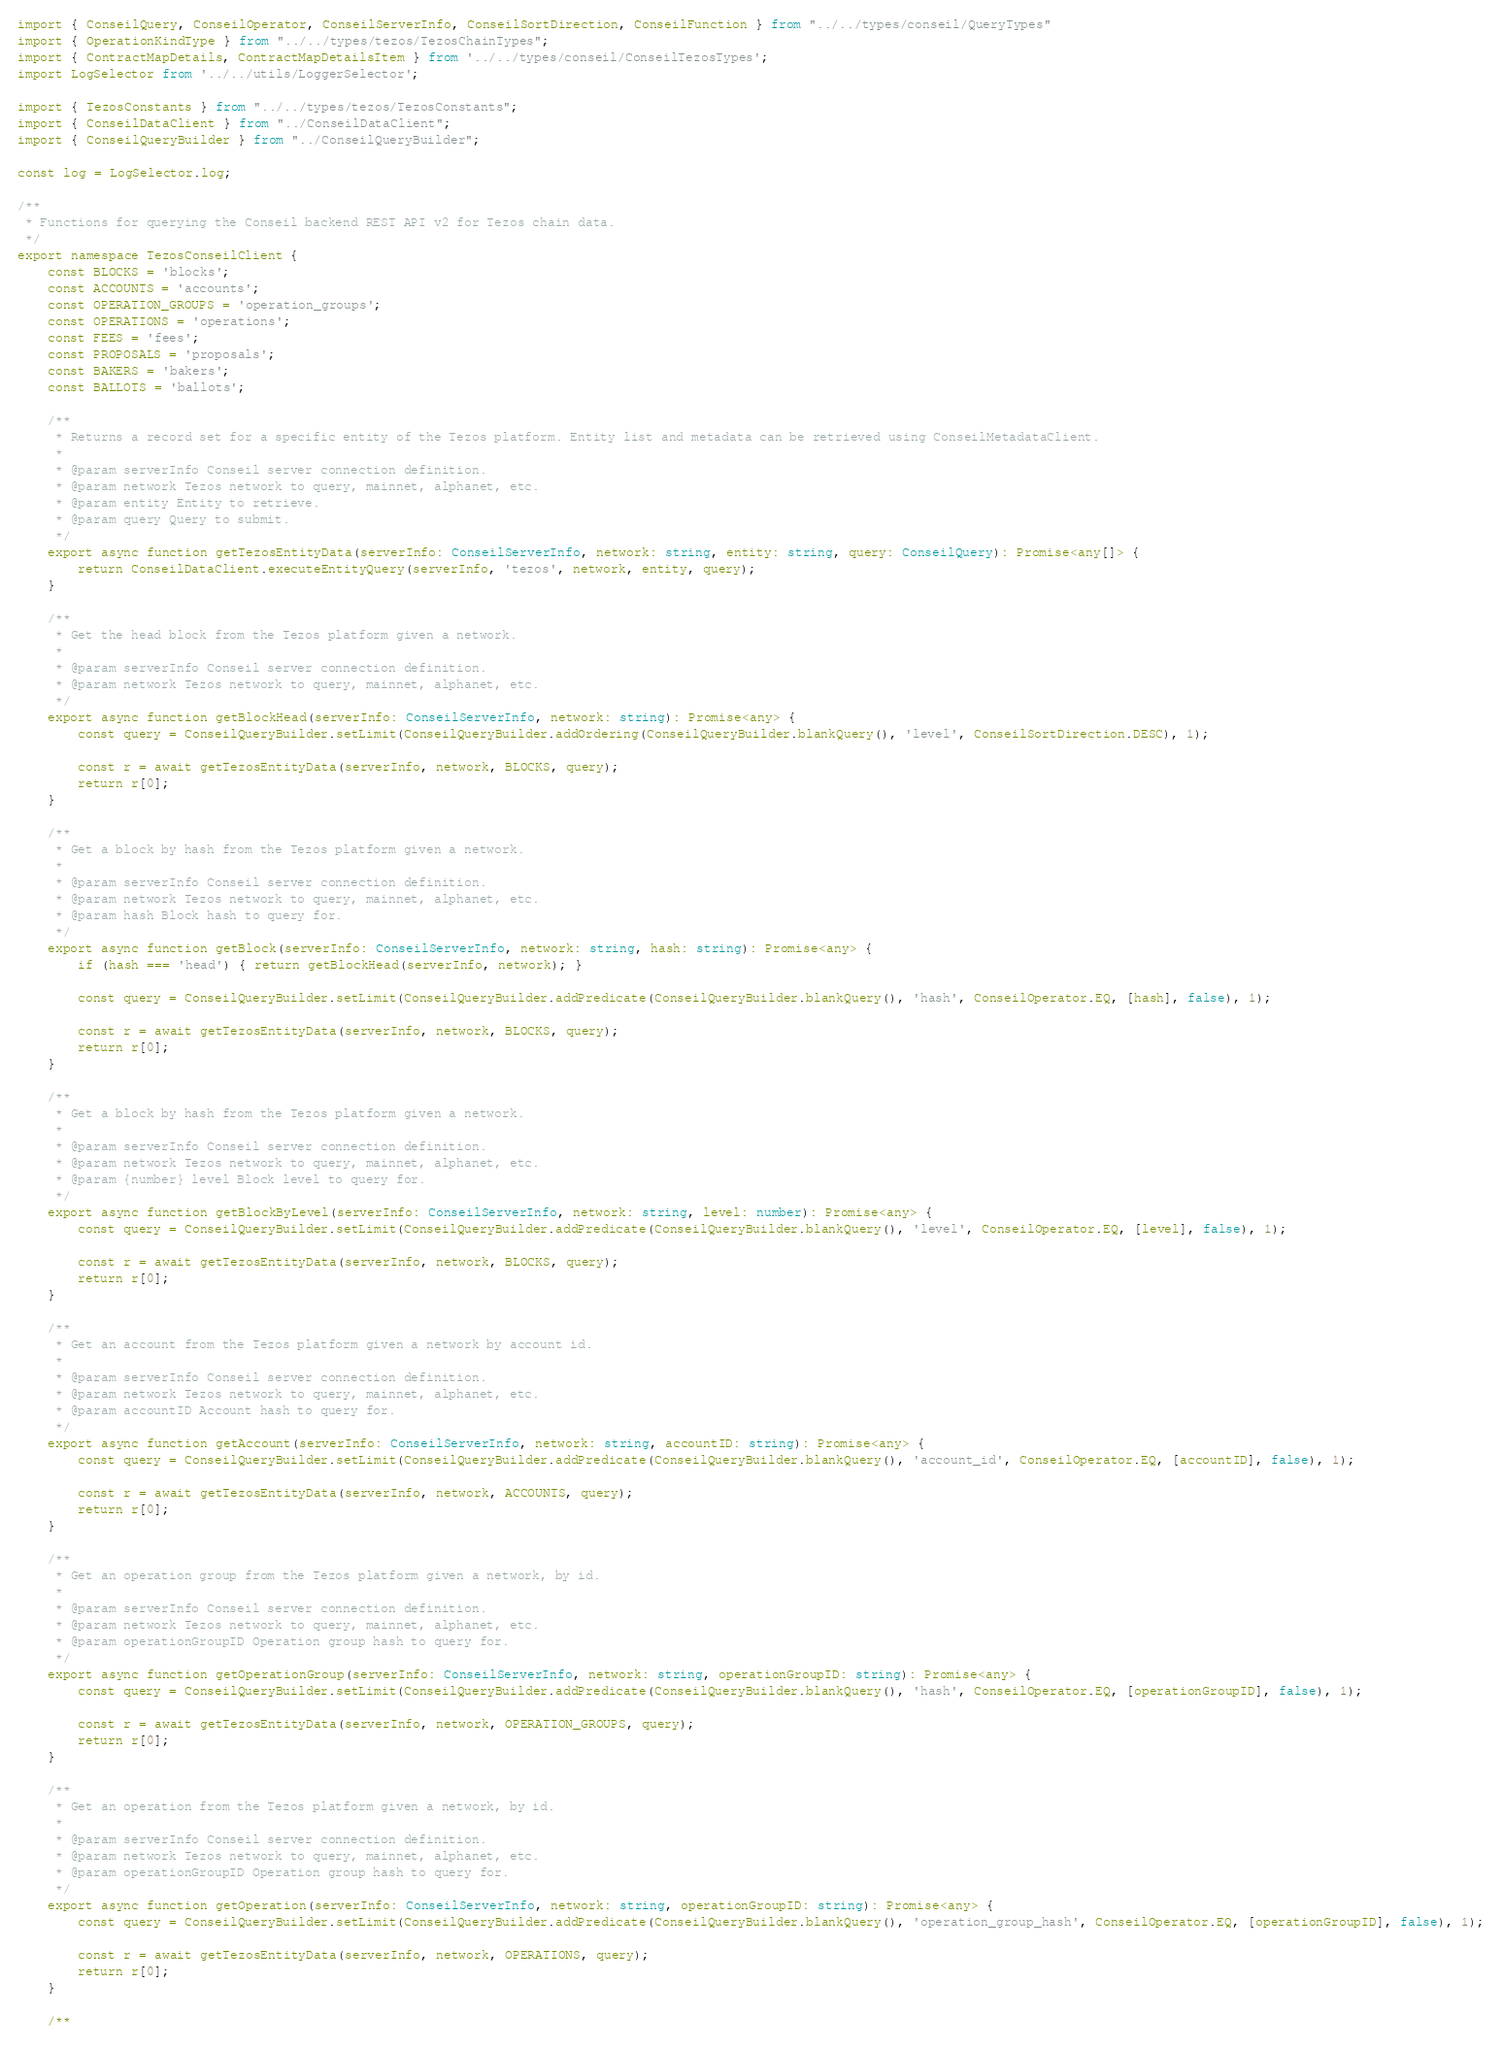<code> <loc_0><loc_0><loc_500><loc_500><_TypeScript_>import { ConseilQuery, ConseilOperator, ConseilServerInfo, ConseilSortDirection, ConseilFunction } from "../../types/conseil/QueryTypes"
import { OperationKindType } from "../../types/tezos/TezosChainTypes";
import { ContractMapDetails, ContractMapDetailsItem } from '../../types/conseil/ConseilTezosTypes';
import LogSelector from '../../utils/LoggerSelector';

import { TezosConstants } from "../../types/tezos/TezosConstants";
import { ConseilDataClient } from "../ConseilDataClient";
import { ConseilQueryBuilder } from "../ConseilQueryBuilder";

const log = LogSelector.log;

/**
 * Functions for querying the Conseil backend REST API v2 for Tezos chain data.
 */
export namespace TezosConseilClient {
    const BLOCKS = 'blocks';
    const ACCOUNTS = 'accounts';
    const OPERATION_GROUPS = 'operation_groups';
    const OPERATIONS = 'operations';
    const FEES = 'fees';
    const PROPOSALS = 'proposals';
    const BAKERS = 'bakers';
    const BALLOTS = 'ballots';

    /**
     * Returns a record set for a specific entity of the Tezos platform. Entity list and metadata can be retrieved using ConseilMetadataClient.
     *
     * @param serverInfo Conseil server connection definition.
     * @param network Tezos network to query, mainnet, alphanet, etc.
     * @param entity Entity to retrieve.
     * @param query Query to submit.
     */
    export async function getTezosEntityData(serverInfo: ConseilServerInfo, network: string, entity: string, query: ConseilQuery): Promise<any[]> {
        return ConseilDataClient.executeEntityQuery(serverInfo, 'tezos', network, entity, query);
    }

    /**
     * Get the head block from the Tezos platform given a network.
     *
     * @param serverInfo Conseil server connection definition.
     * @param network Tezos network to query, mainnet, alphanet, etc.
     */
    export async function getBlockHead(serverInfo: ConseilServerInfo, network: string): Promise<any> {
        const query = ConseilQueryBuilder.setLimit(ConseilQueryBuilder.addOrdering(ConseilQueryBuilder.blankQuery(), 'level', ConseilSortDirection.DESC), 1);

        const r = await getTezosEntityData(serverInfo, network, BLOCKS, query);
        return r[0];
    }

    /**
     * Get a block by hash from the Tezos platform given a network.
     *
     * @param serverInfo Conseil server connection definition.
     * @param network Tezos network to query, mainnet, alphanet, etc.
     * @param hash Block hash to query for.
     */
    export async function getBlock(serverInfo: ConseilServerInfo, network: string, hash: string): Promise<any> {
        if (hash === 'head') { return getBlockHead(serverInfo, network); }

        const query = ConseilQueryBuilder.setLimit(ConseilQueryBuilder.addPredicate(ConseilQueryBuilder.blankQuery(), 'hash', ConseilOperator.EQ, [hash], false), 1);

        const r = await getTezosEntityData(serverInfo, network, BLOCKS, query);
        return r[0];
    }

    /**
     * Get a block by hash from the Tezos platform given a network.
     *
     * @param serverInfo Conseil server connection definition.
     * @param network Tezos network to query, mainnet, alphanet, etc.
     * @param {number} level Block level to query for.
     */
    export async function getBlockByLevel(serverInfo: ConseilServerInfo, network: string, level: number): Promise<any> {
        const query = ConseilQueryBuilder.setLimit(ConseilQueryBuilder.addPredicate(ConseilQueryBuilder.blankQuery(), 'level', ConseilOperator.EQ, [level], false), 1);

        const r = await getTezosEntityData(serverInfo, network, BLOCKS, query);
        return r[0];
    }

    /**
     * Get an account from the Tezos platform given a network by account id.
     *
     * @param serverInfo Conseil server connection definition.
     * @param network Tezos network to query, mainnet, alphanet, etc.
     * @param accountID Account hash to query for.
     */
    export async function getAccount(serverInfo: ConseilServerInfo, network: string, accountID: string): Promise<any> {
        const query = ConseilQueryBuilder.setLimit(ConseilQueryBuilder.addPredicate(ConseilQueryBuilder.blankQuery(), 'account_id', ConseilOperator.EQ, [accountID], false), 1);

        const r = await getTezosEntityData(serverInfo, network, ACCOUNTS, query);
        return r[0];
    }

    /**
     * Get an operation group from the Tezos platform given a network, by id.
     *
     * @param serverInfo Conseil server connection definition.
     * @param network Tezos network to query, mainnet, alphanet, etc.
     * @param operationGroupID Operation group hash to query for.
     */
    export async function getOperationGroup(serverInfo: ConseilServerInfo, network: string, operationGroupID: string): Promise<any> {
        const query = ConseilQueryBuilder.setLimit(ConseilQueryBuilder.addPredicate(ConseilQueryBuilder.blankQuery(), 'hash', ConseilOperator.EQ, [operationGroupID], false), 1);

        const r = await getTezosEntityData(serverInfo, network, OPERATION_GROUPS, query);
        return r[0];
    }

    /**
     * Get an operation from the Tezos platform given a network, by id.
     *
     * @param serverInfo Conseil server connection definition.
     * @param network Tezos network to query, mainnet, alphanet, etc.
     * @param operationGroupID Operation group hash to query for.
     */
    export async function getOperation(serverInfo: ConseilServerInfo, network: string, operationGroupID: string): Promise<any> {
        const query = ConseilQueryBuilder.setLimit(ConseilQueryBuilder.addPredicate(ConseilQueryBuilder.blankQuery(), 'operation_group_hash', ConseilOperator.EQ, [operationGroupID], false), 1);

        const r = await getTezosEntityData(serverInfo, network, OPERATIONS, query);
        return r[0];
    }

    /**</code> 